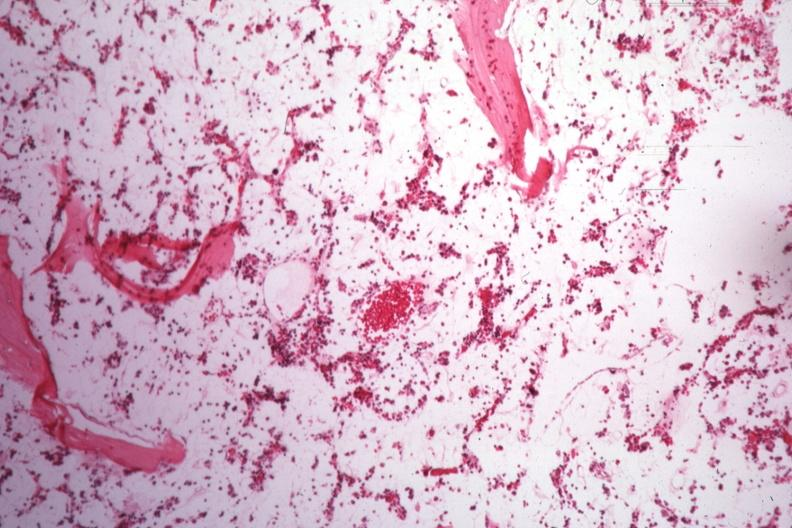s aplastic present?
Answer the question using a single word or phrase. Yes 